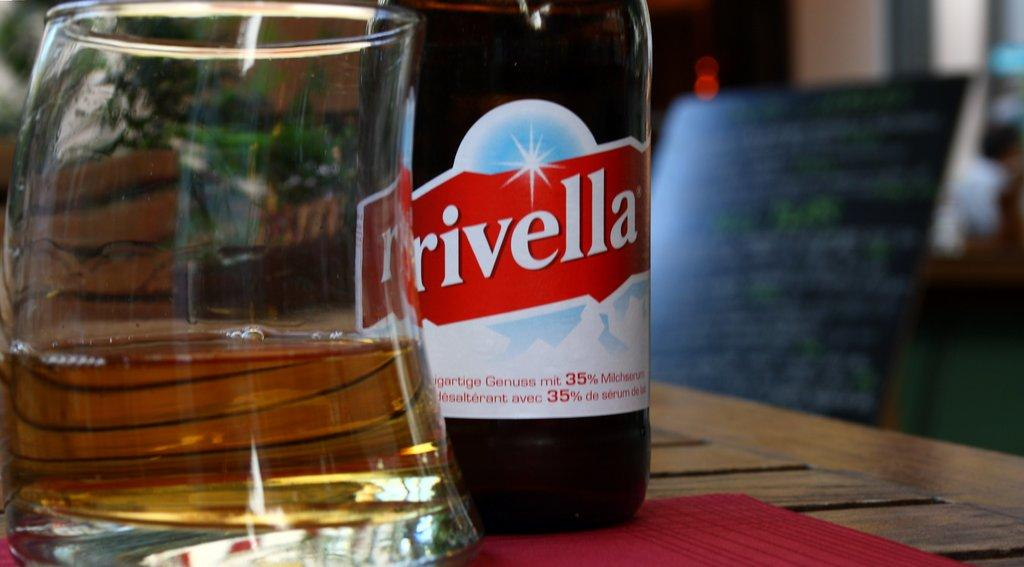Provide a one-sentence caption for the provided image. a bottle of red Rivella standing next to a glass. 